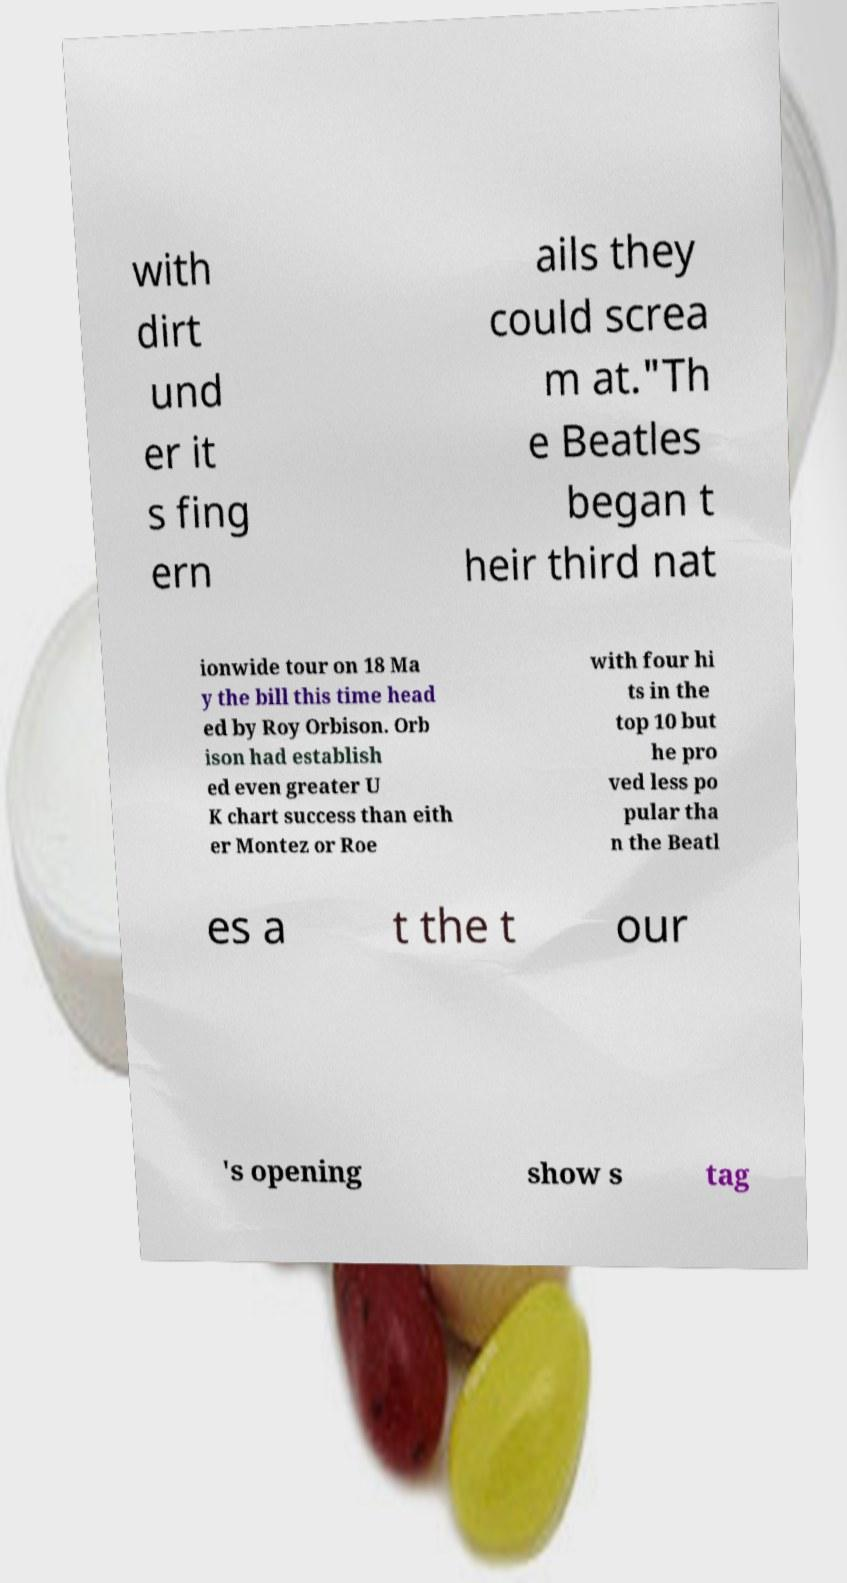I need the written content from this picture converted into text. Can you do that? with dirt und er it s fing ern ails they could screa m at."Th e Beatles began t heir third nat ionwide tour on 18 Ma y the bill this time head ed by Roy Orbison. Orb ison had establish ed even greater U K chart success than eith er Montez or Roe with four hi ts in the top 10 but he pro ved less po pular tha n the Beatl es a t the t our 's opening show s tag 